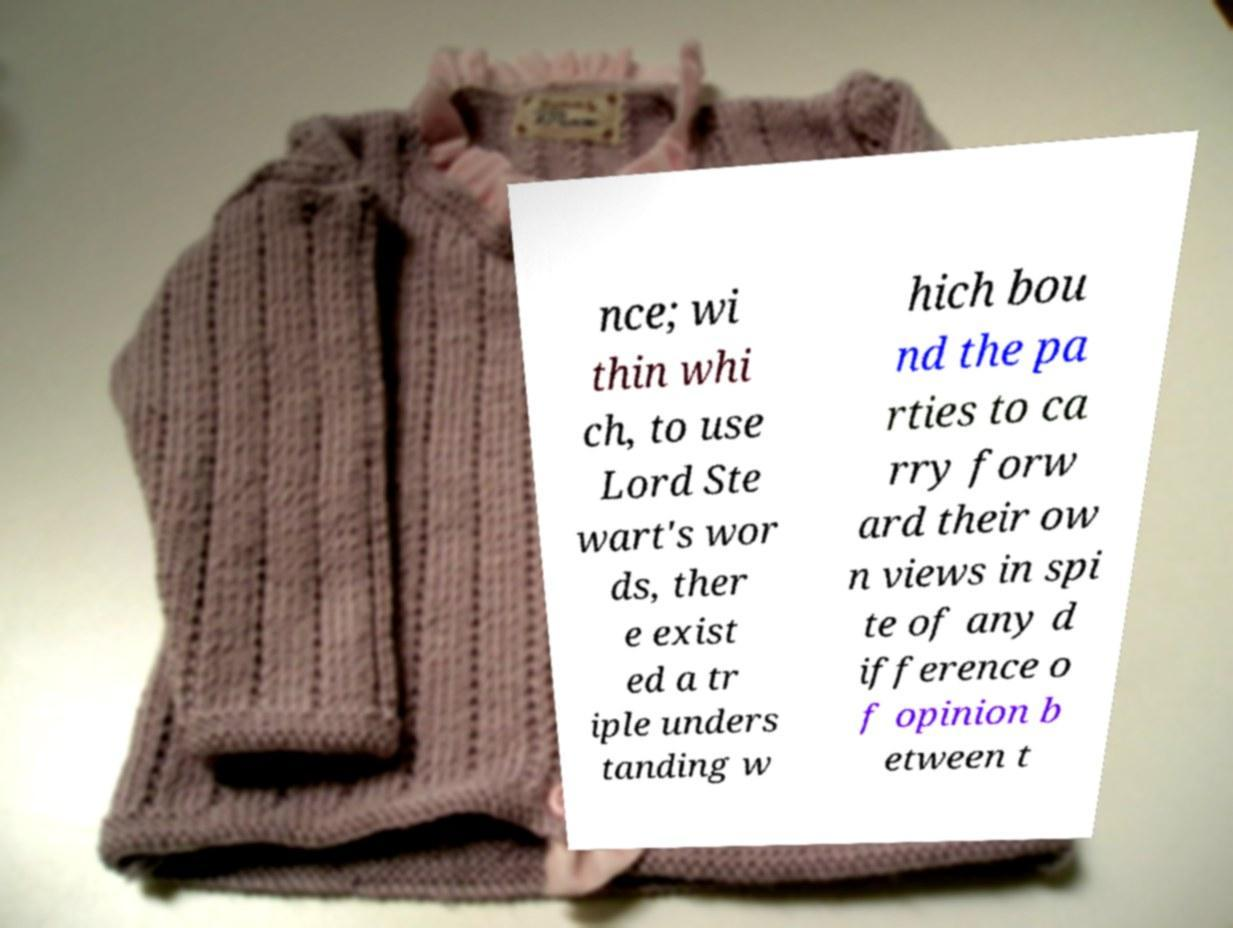What messages or text are displayed in this image? I need them in a readable, typed format. nce; wi thin whi ch, to use Lord Ste wart's wor ds, ther e exist ed a tr iple unders tanding w hich bou nd the pa rties to ca rry forw ard their ow n views in spi te of any d ifference o f opinion b etween t 